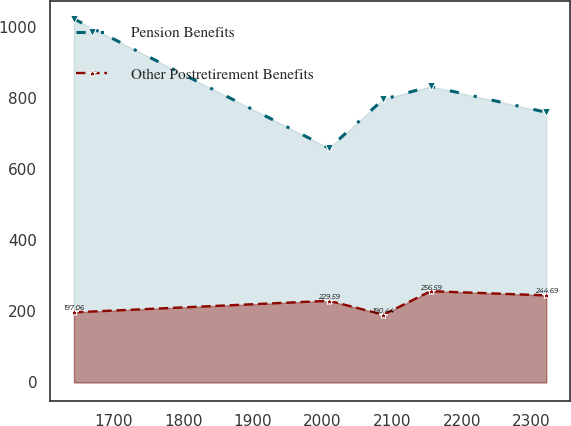<chart> <loc_0><loc_0><loc_500><loc_500><line_chart><ecel><fcel>Pension Benefits<fcel>Other Postretirement Benefits<nl><fcel>1643.05<fcel>1021.38<fcel>197.06<nl><fcel>2009.44<fcel>658.15<fcel>229.59<nl><fcel>2087.36<fcel>795.48<fcel>190.44<nl><fcel>2155.18<fcel>831.8<fcel>256.59<nl><fcel>2321.26<fcel>759.16<fcel>244.69<nl></chart> 